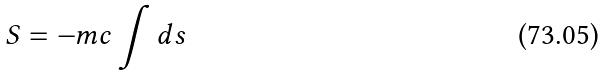Convert formula to latex. <formula><loc_0><loc_0><loc_500><loc_500>S = - m c \int d s</formula> 